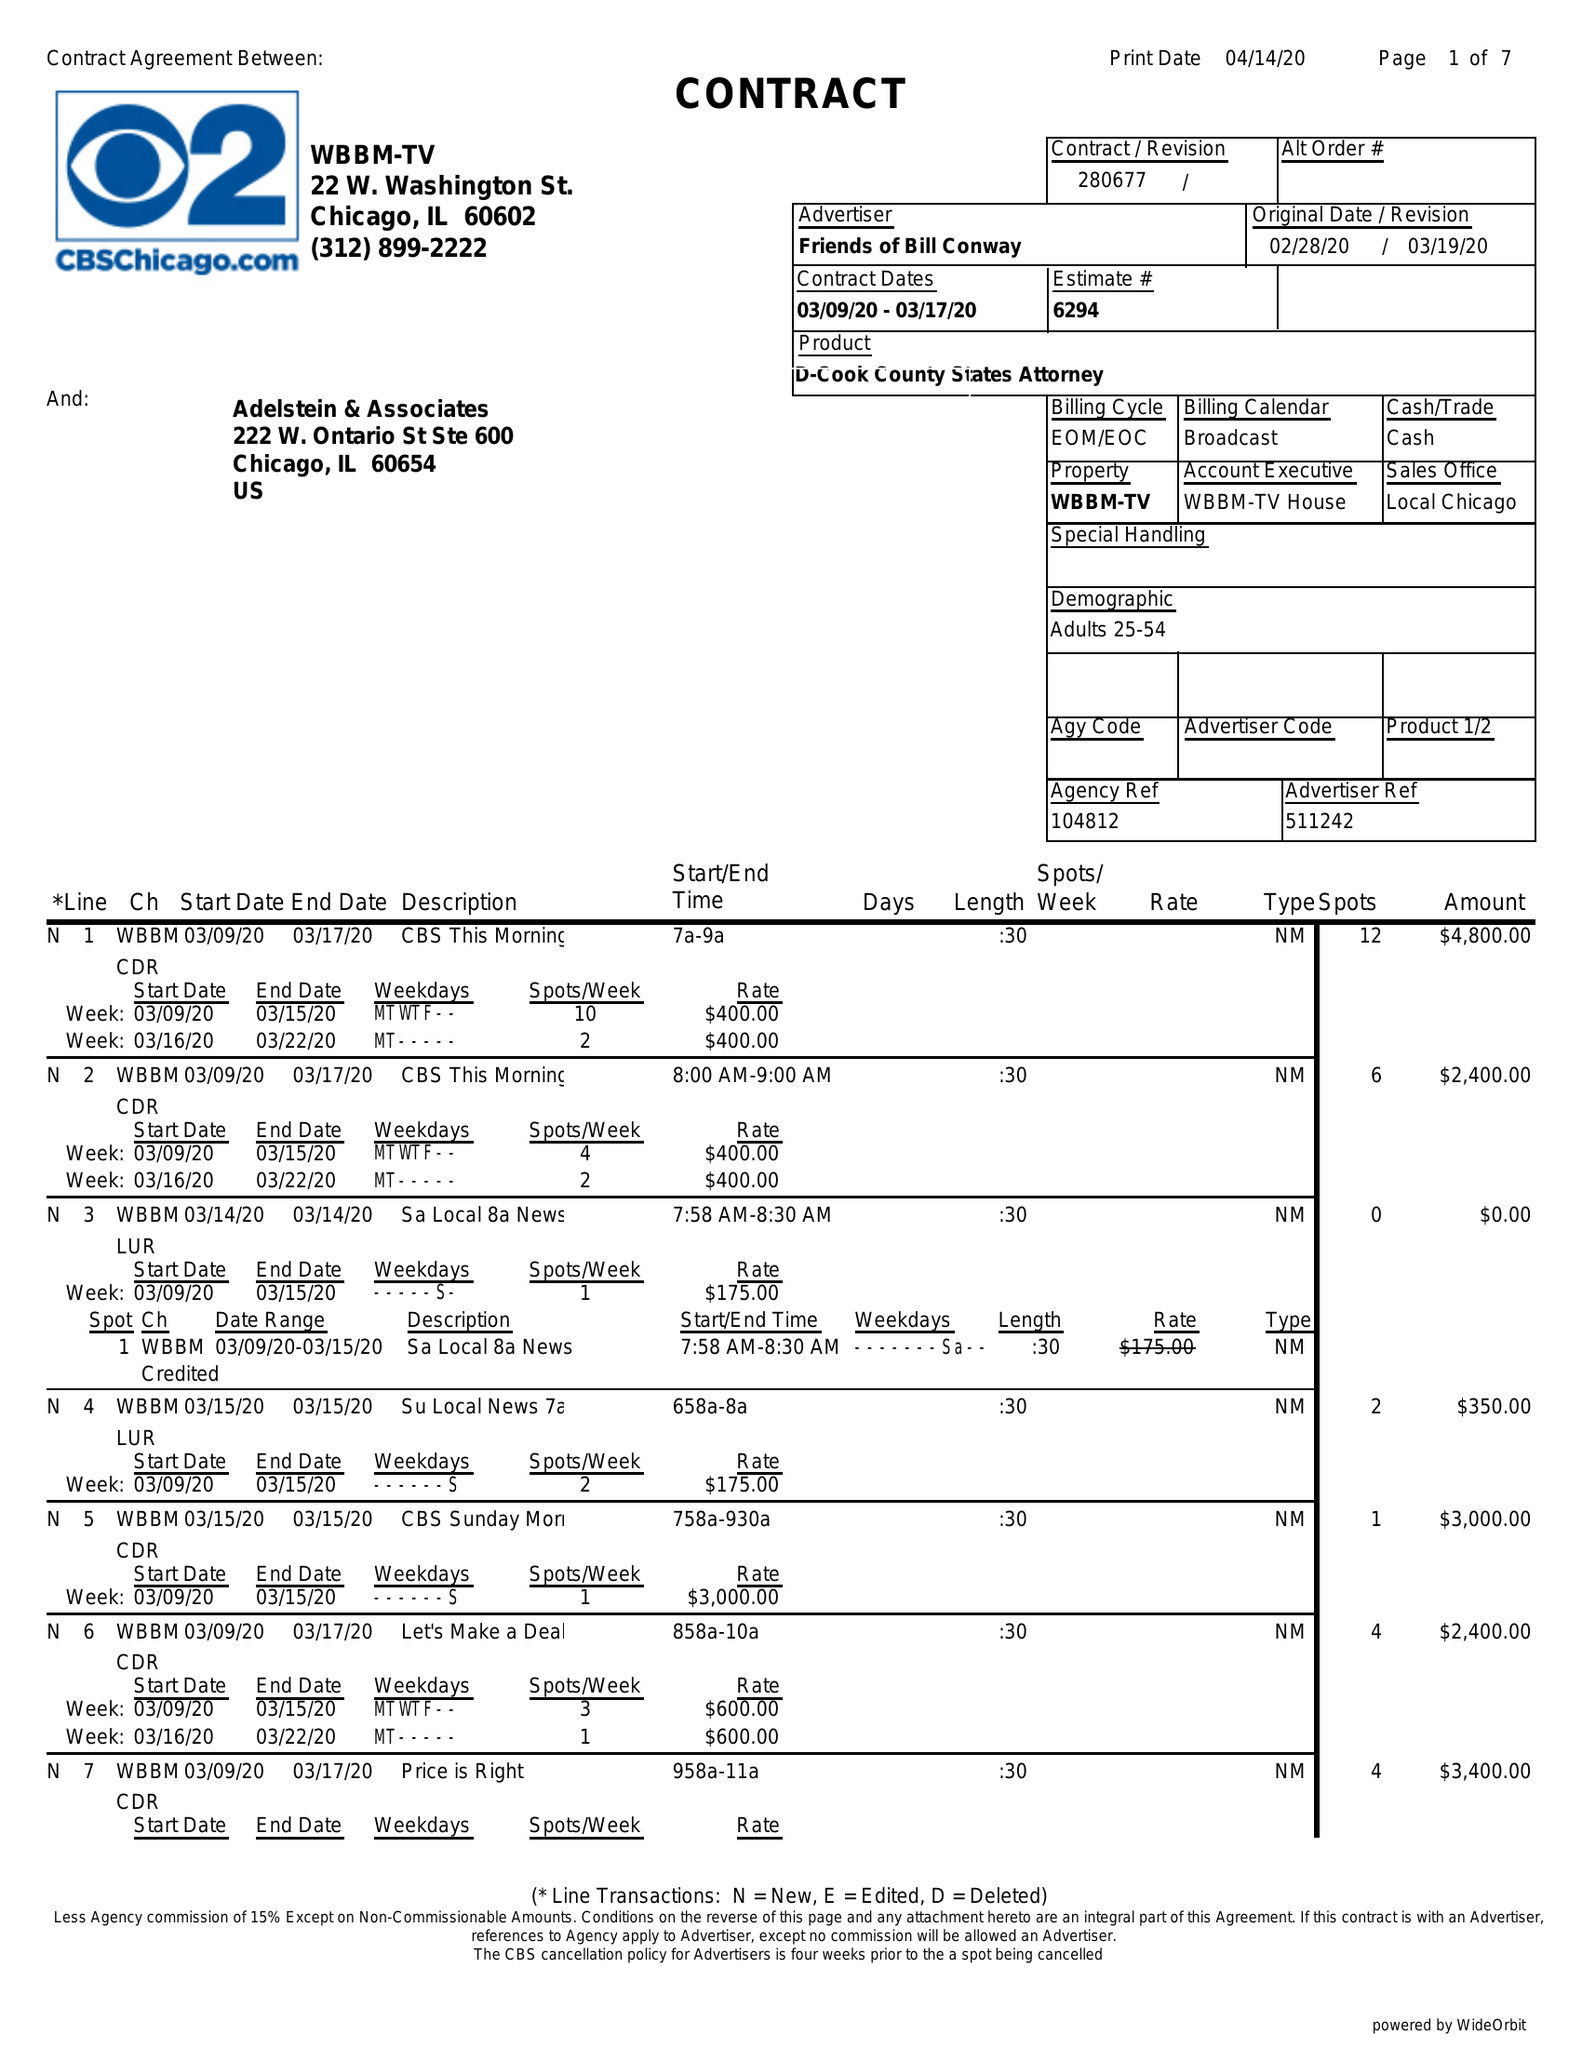What is the value for the advertiser?
Answer the question using a single word or phrase. FRIENDS OF BILL CONWAY 